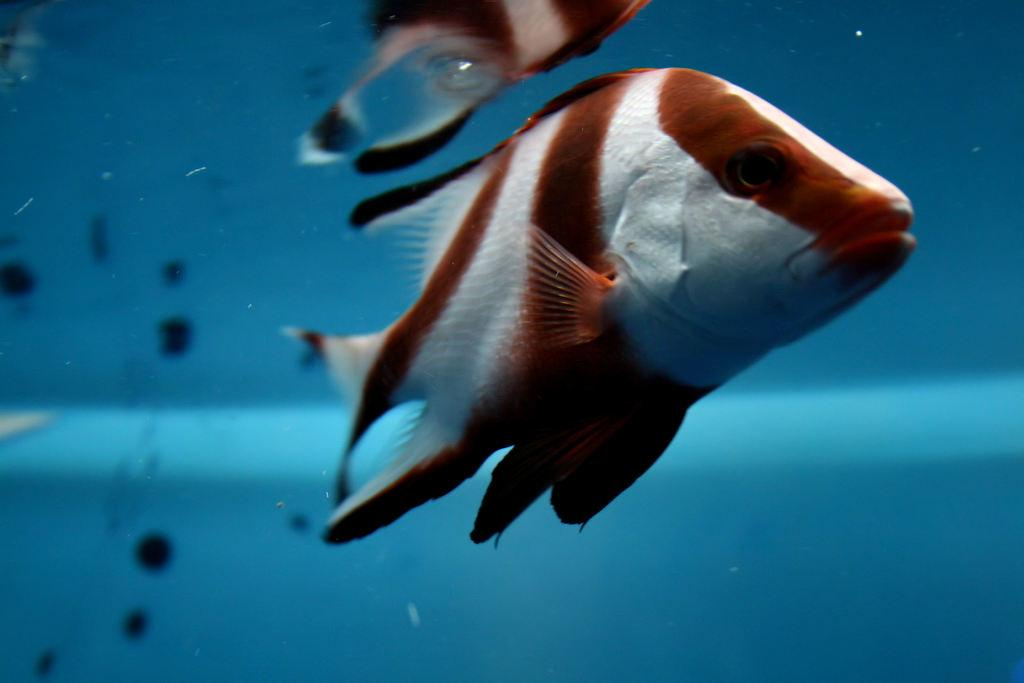What is the focus of the image? The image is zoomed in on a specific area. What can be seen in the water body in the image? There are two fishes swimming in the water body. What else can be seen in the background of the image? There are other objects visible in the background of the image. How many spiders are crawling on the lamp in the image? There are no spiders or lamp present in the image; it features two fishes swimming in a water body. 